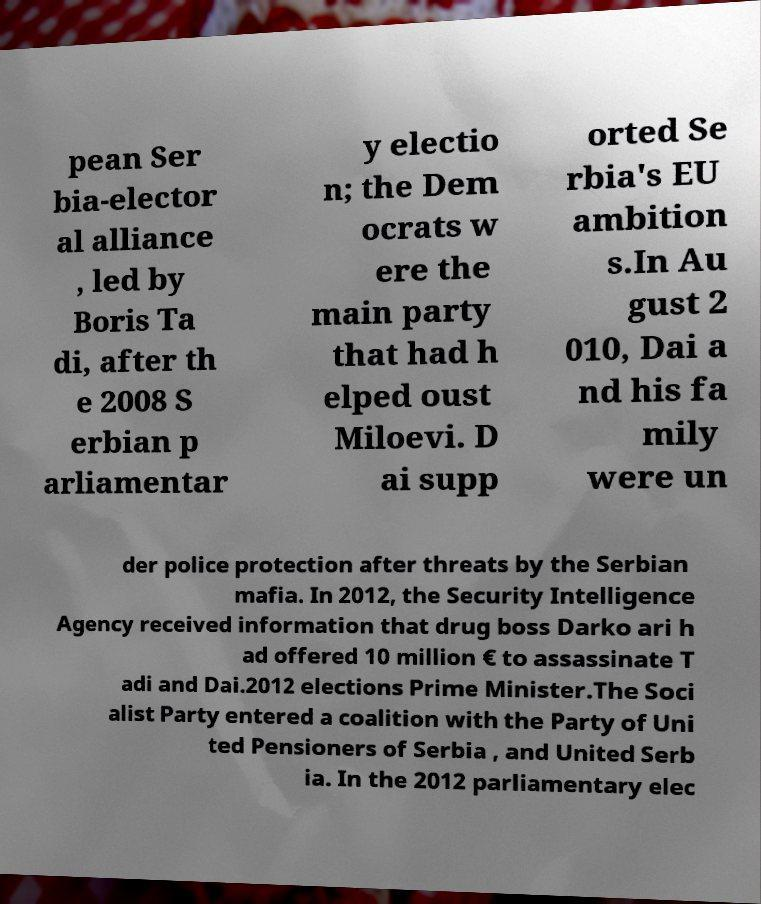I need the written content from this picture converted into text. Can you do that? pean Ser bia-elector al alliance , led by Boris Ta di, after th e 2008 S erbian p arliamentar y electio n; the Dem ocrats w ere the main party that had h elped oust Miloevi. D ai supp orted Se rbia's EU ambition s.In Au gust 2 010, Dai a nd his fa mily were un der police protection after threats by the Serbian mafia. In 2012, the Security Intelligence Agency received information that drug boss Darko ari h ad offered 10 million € to assassinate T adi and Dai.2012 elections Prime Minister.The Soci alist Party entered a coalition with the Party of Uni ted Pensioners of Serbia , and United Serb ia. In the 2012 parliamentary elec 